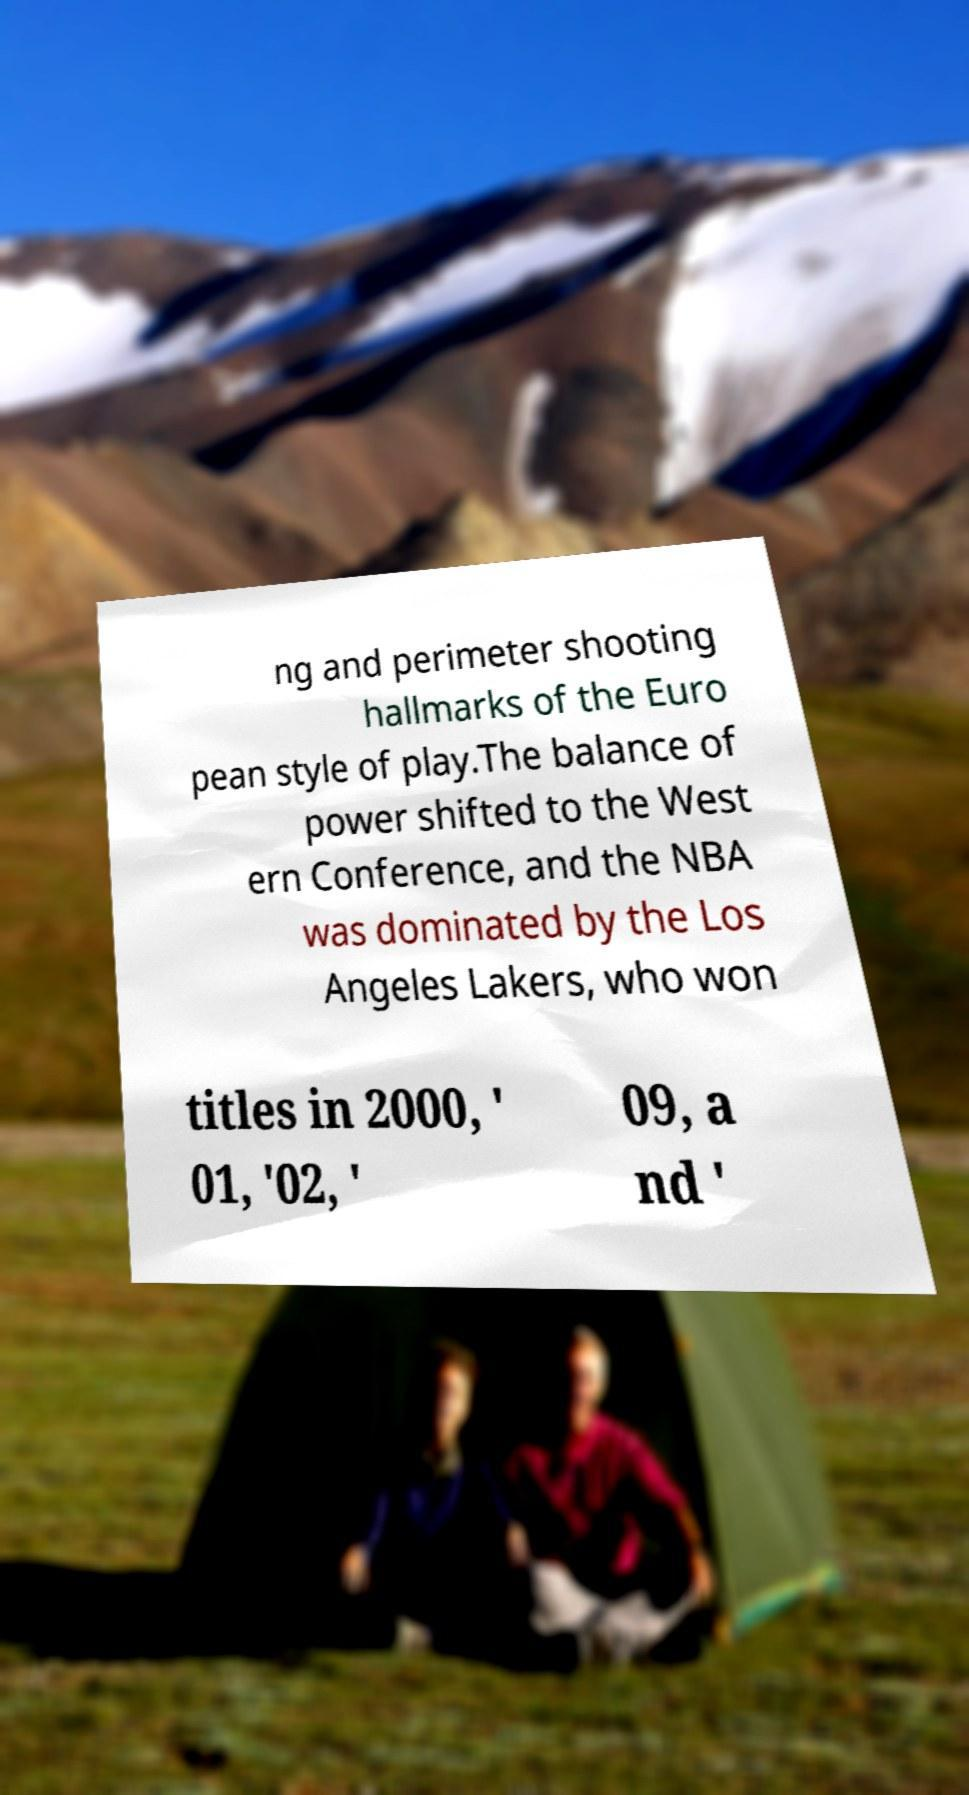There's text embedded in this image that I need extracted. Can you transcribe it verbatim? ng and perimeter shooting hallmarks of the Euro pean style of play.The balance of power shifted to the West ern Conference, and the NBA was dominated by the Los Angeles Lakers, who won titles in 2000, ' 01, '02, ' 09, a nd ' 